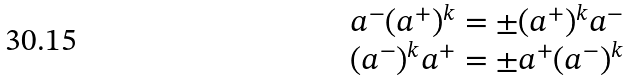<formula> <loc_0><loc_0><loc_500><loc_500>\begin{array} { c } { { a ^ { - } ( a ^ { + } ) ^ { k } = \pm ( a ^ { + } ) ^ { k } a ^ { - } } } \\ { { ( a ^ { - } ) ^ { k } a ^ { + } = \pm a ^ { + } ( a ^ { - } ) ^ { k } } } \end{array}</formula> 